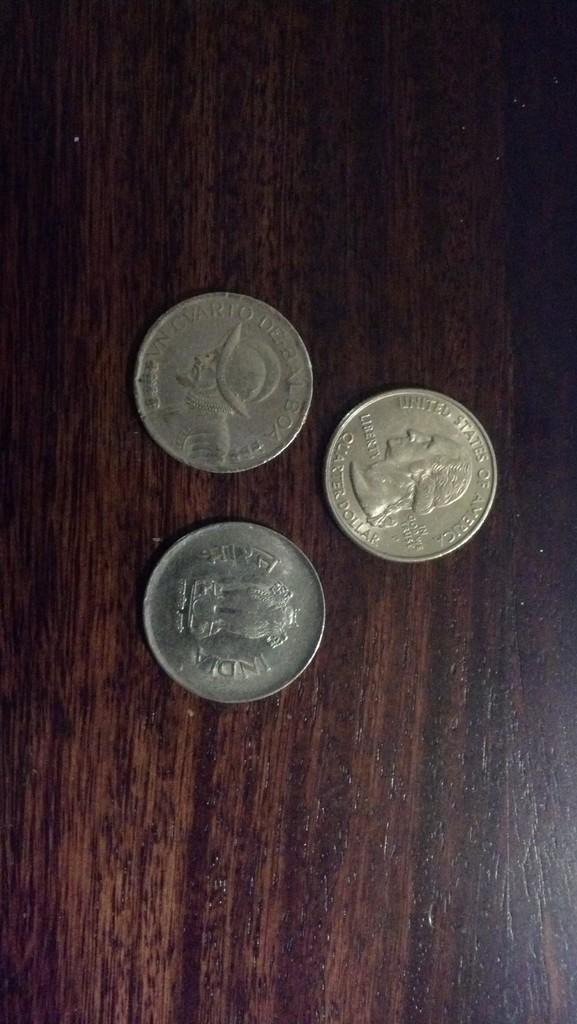<image>
Relay a brief, clear account of the picture shown. Three coins sit on a desk and one of them says United States of America. 